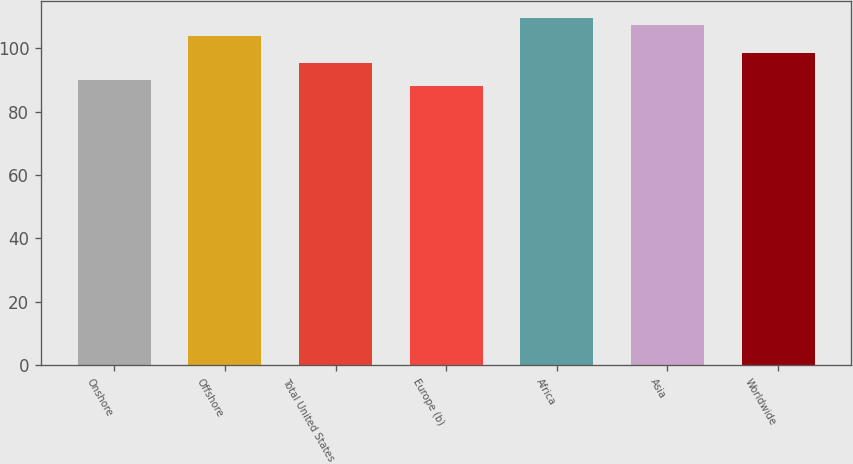Convert chart. <chart><loc_0><loc_0><loc_500><loc_500><bar_chart><fcel>Onshore<fcel>Offshore<fcel>Total United States<fcel>Europe (b)<fcel>Africa<fcel>Asia<fcel>Worldwide<nl><fcel>90.1<fcel>103.83<fcel>95.5<fcel>88.03<fcel>109.47<fcel>107.4<fcel>98.48<nl></chart> 